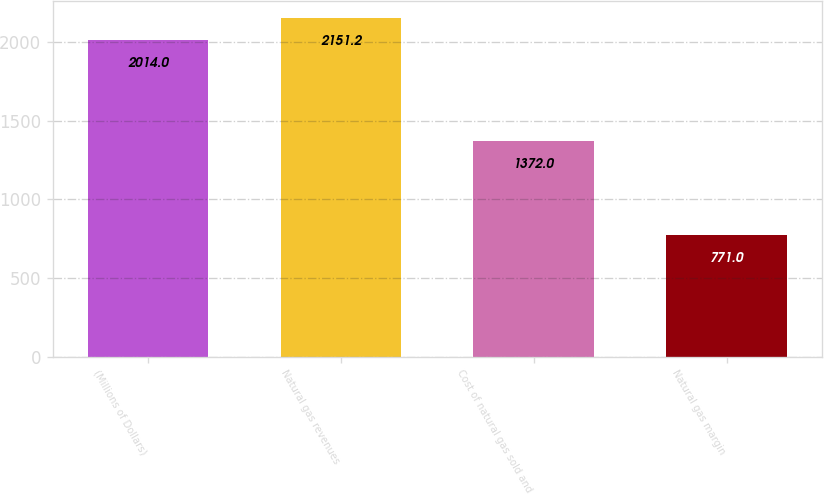<chart> <loc_0><loc_0><loc_500><loc_500><bar_chart><fcel>(Millions of Dollars)<fcel>Natural gas revenues<fcel>Cost of natural gas sold and<fcel>Natural gas margin<nl><fcel>2014<fcel>2151.2<fcel>1372<fcel>771<nl></chart> 